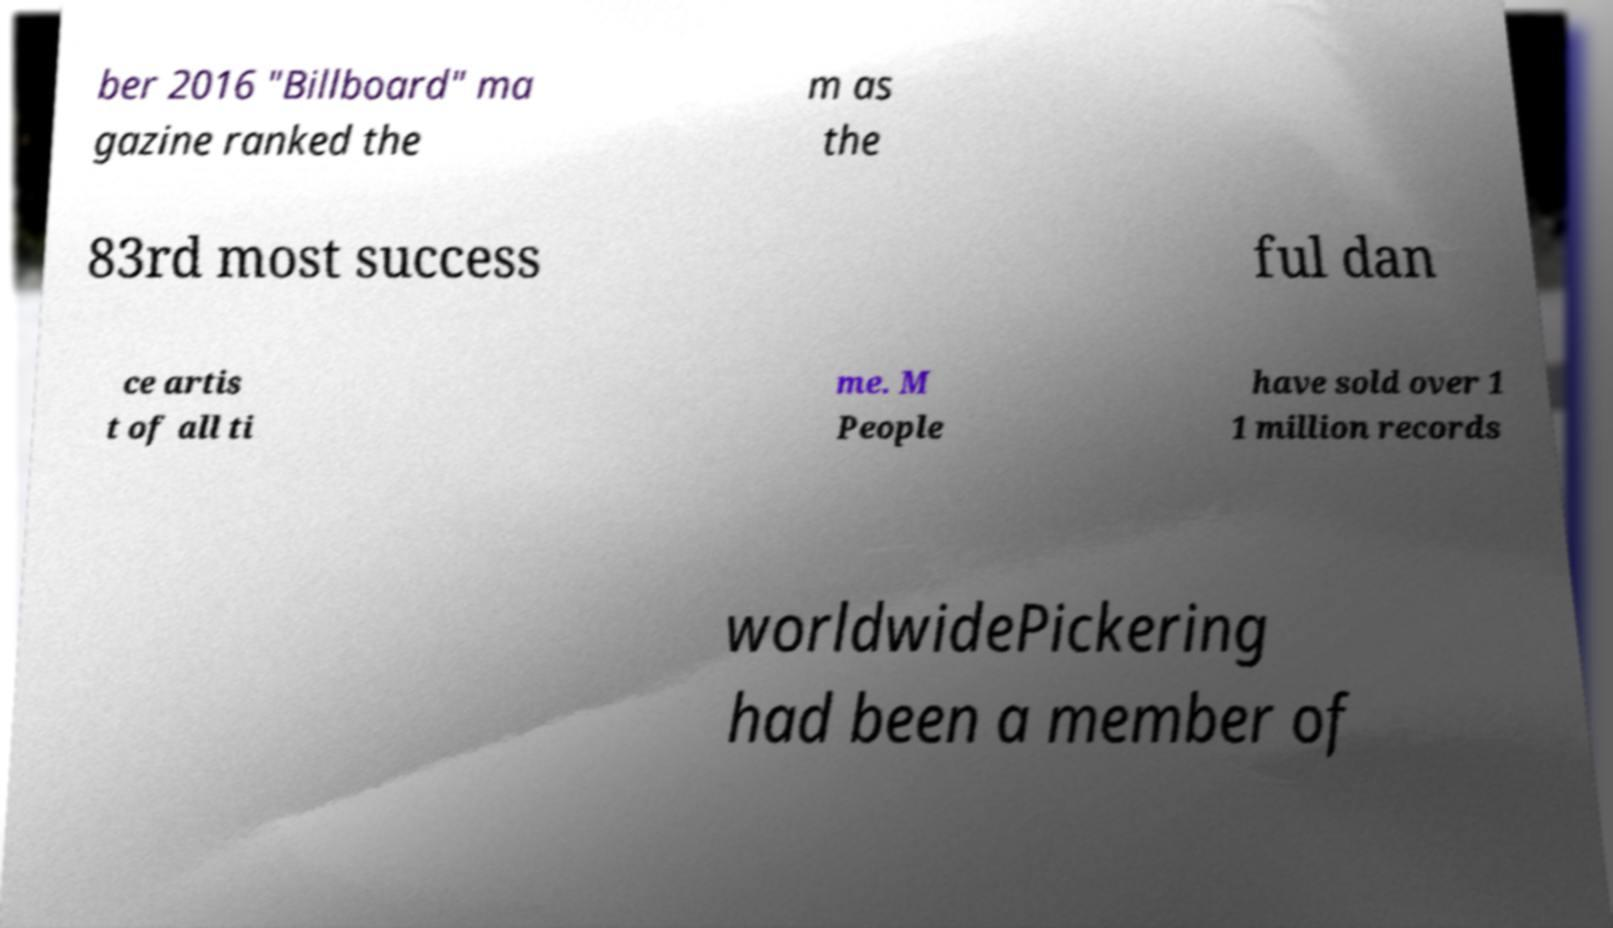Can you read and provide the text displayed in the image?This photo seems to have some interesting text. Can you extract and type it out for me? ber 2016 "Billboard" ma gazine ranked the m as the 83rd most success ful dan ce artis t of all ti me. M People have sold over 1 1 million records worldwidePickering had been a member of 